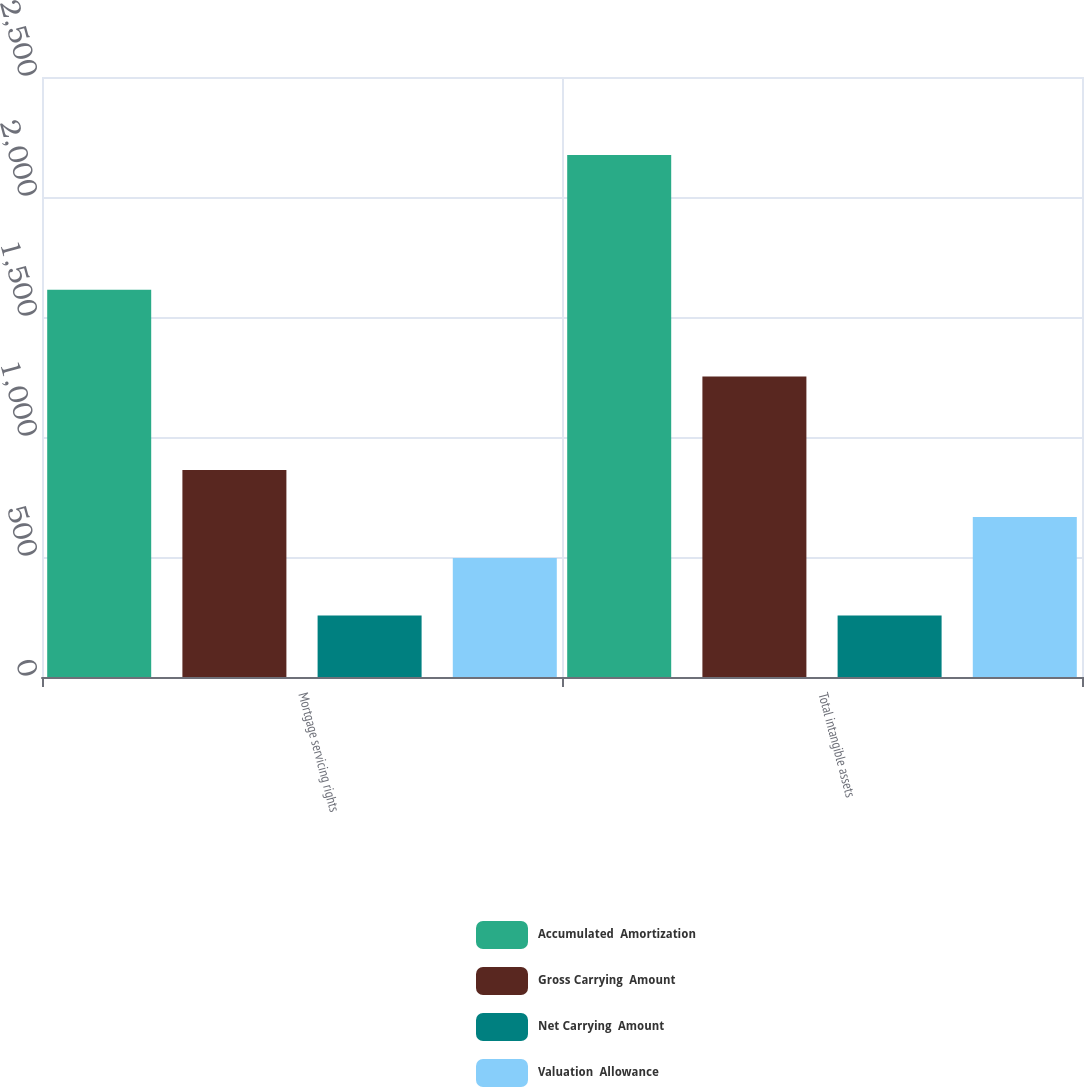<chart> <loc_0><loc_0><loc_500><loc_500><stacked_bar_chart><ecel><fcel>Mortgage servicing rights<fcel>Total intangible assets<nl><fcel>Accumulated  Amortization<fcel>1614<fcel>2175<nl><fcel>Gross Carrying  Amount<fcel>862<fcel>1252<nl><fcel>Net Carrying  Amount<fcel>256<fcel>256<nl><fcel>Valuation  Allowance<fcel>496<fcel>667<nl></chart> 